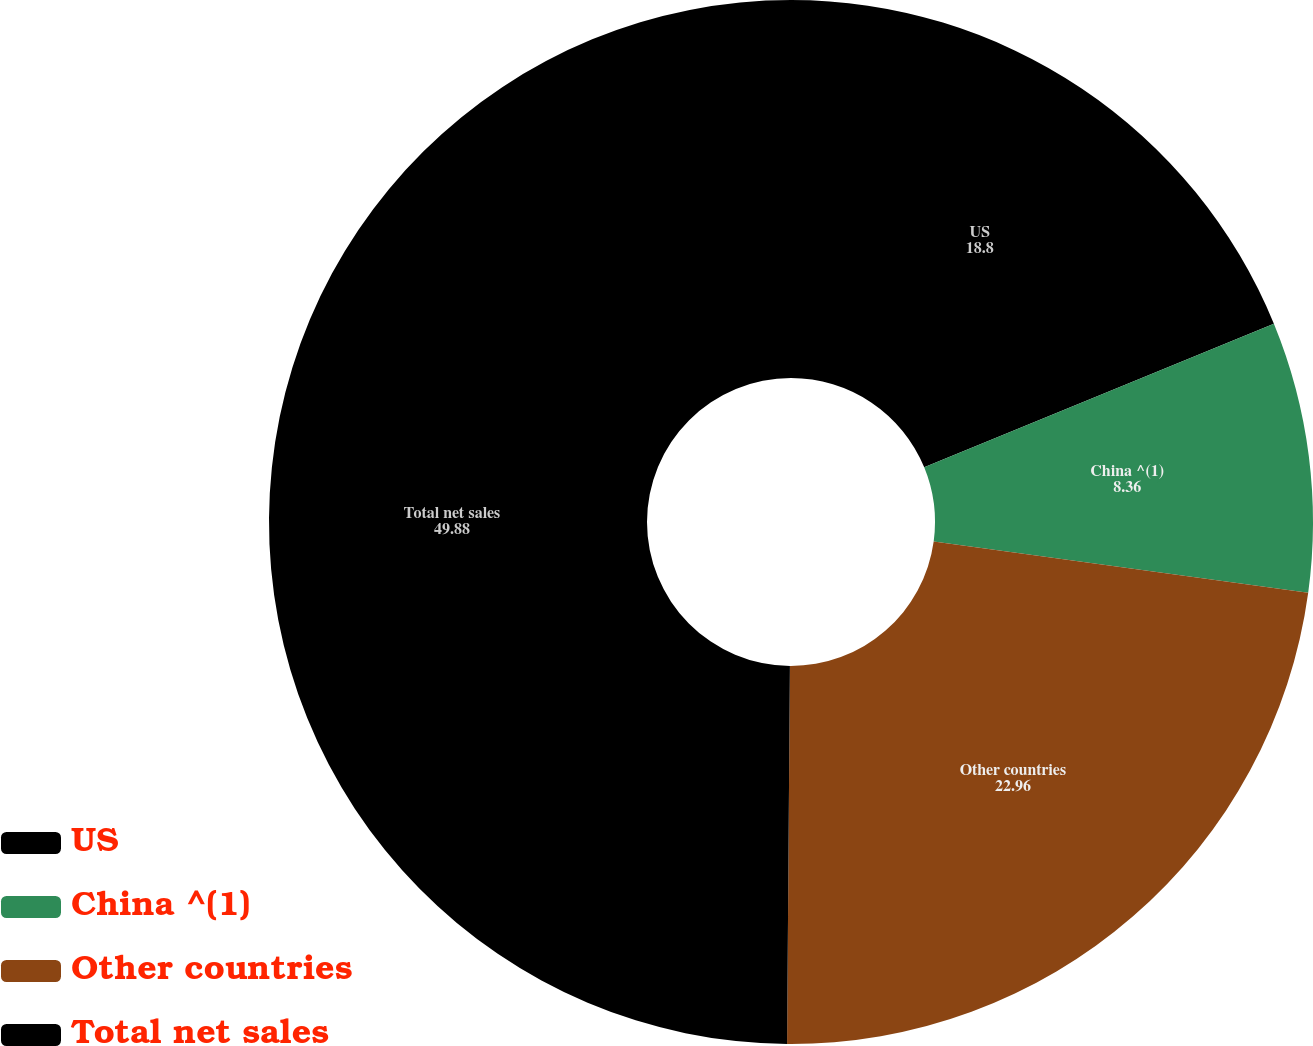Convert chart. <chart><loc_0><loc_0><loc_500><loc_500><pie_chart><fcel>US<fcel>China ^(1)<fcel>Other countries<fcel>Total net sales<nl><fcel>18.8%<fcel>8.36%<fcel>22.96%<fcel>49.88%<nl></chart> 